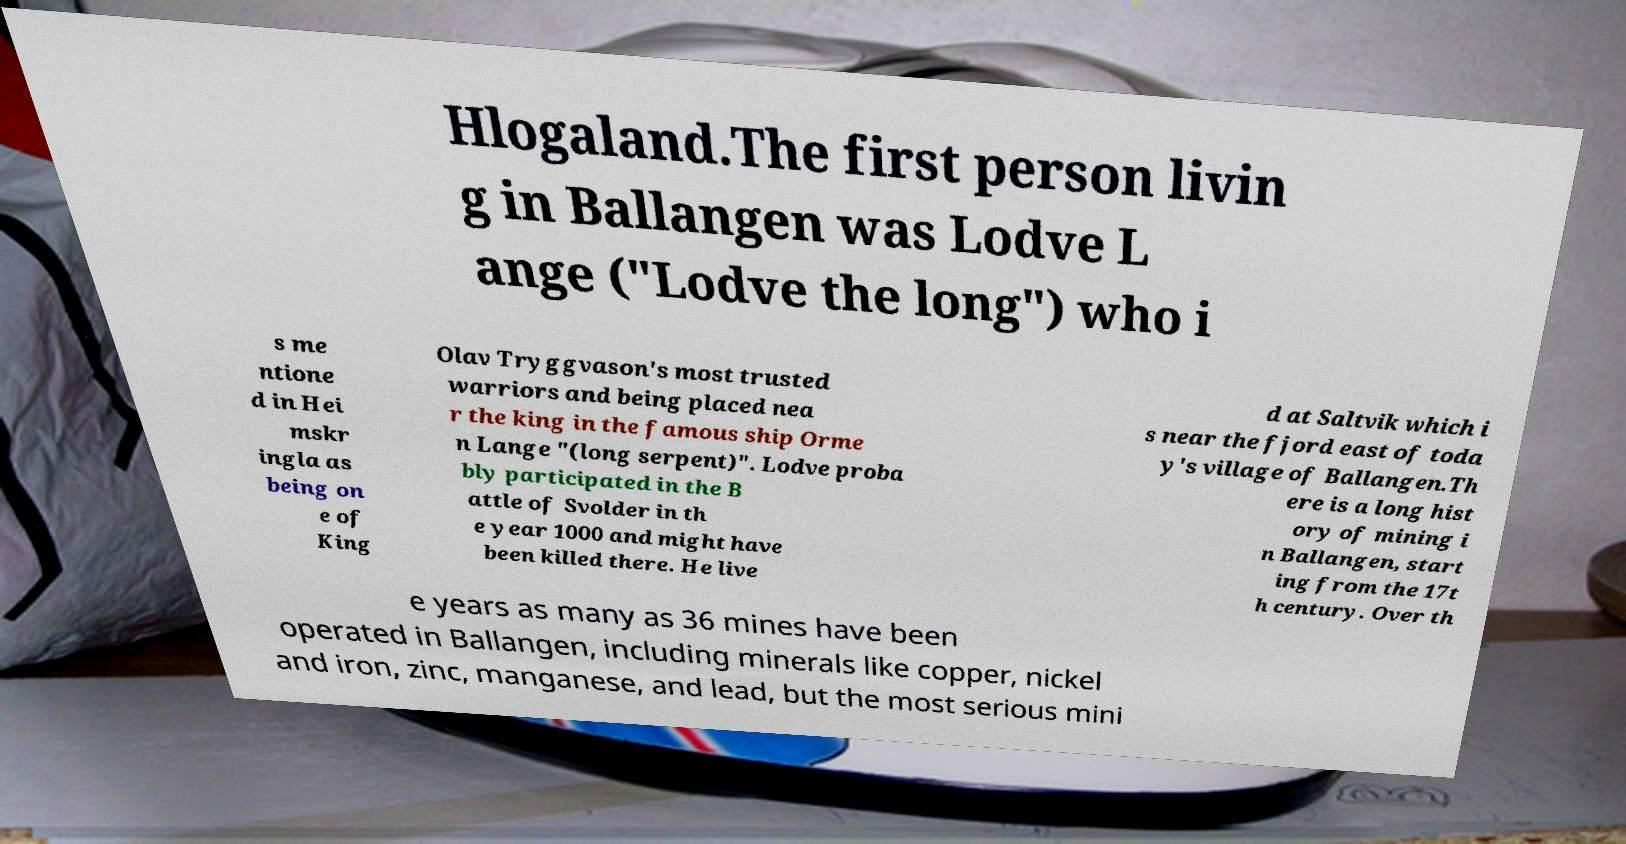Could you assist in decoding the text presented in this image and type it out clearly? Hlogaland.The first person livin g in Ballangen was Lodve L ange ("Lodve the long") who i s me ntione d in Hei mskr ingla as being on e of King Olav Tryggvason's most trusted warriors and being placed nea r the king in the famous ship Orme n Lange "(long serpent)". Lodve proba bly participated in the B attle of Svolder in th e year 1000 and might have been killed there. He live d at Saltvik which i s near the fjord east of toda y's village of Ballangen.Th ere is a long hist ory of mining i n Ballangen, start ing from the 17t h century. Over th e years as many as 36 mines have been operated in Ballangen, including minerals like copper, nickel and iron, zinc, manganese, and lead, but the most serious mini 